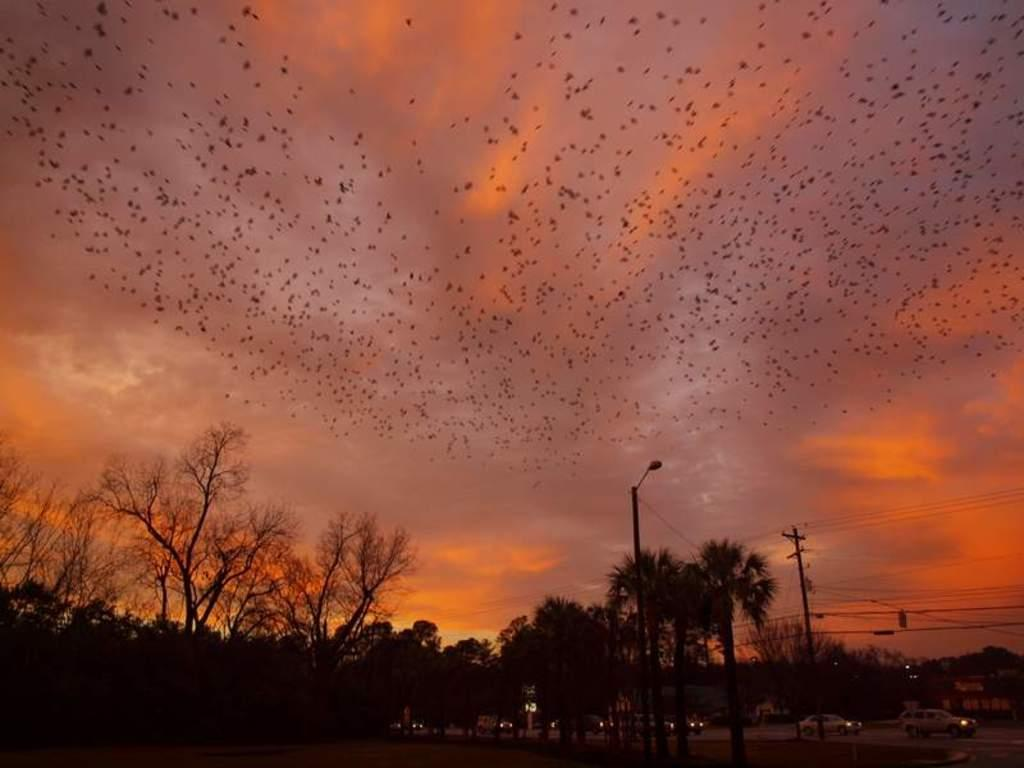What type of vegetation is present at the bottom of the image? There are trees at the bottom of the image. What structures can be seen at the bottom of the image? There are light poles at the bottom of the image. What is visible in the sky at the top of the image? There are birds and clouds visible in the sky at the top of the image. What type of transportation is present in the image? There are cars on the road in the image. What sense is being used by the tank in the image? There is no tank present in the image, so this question cannot be answered. 